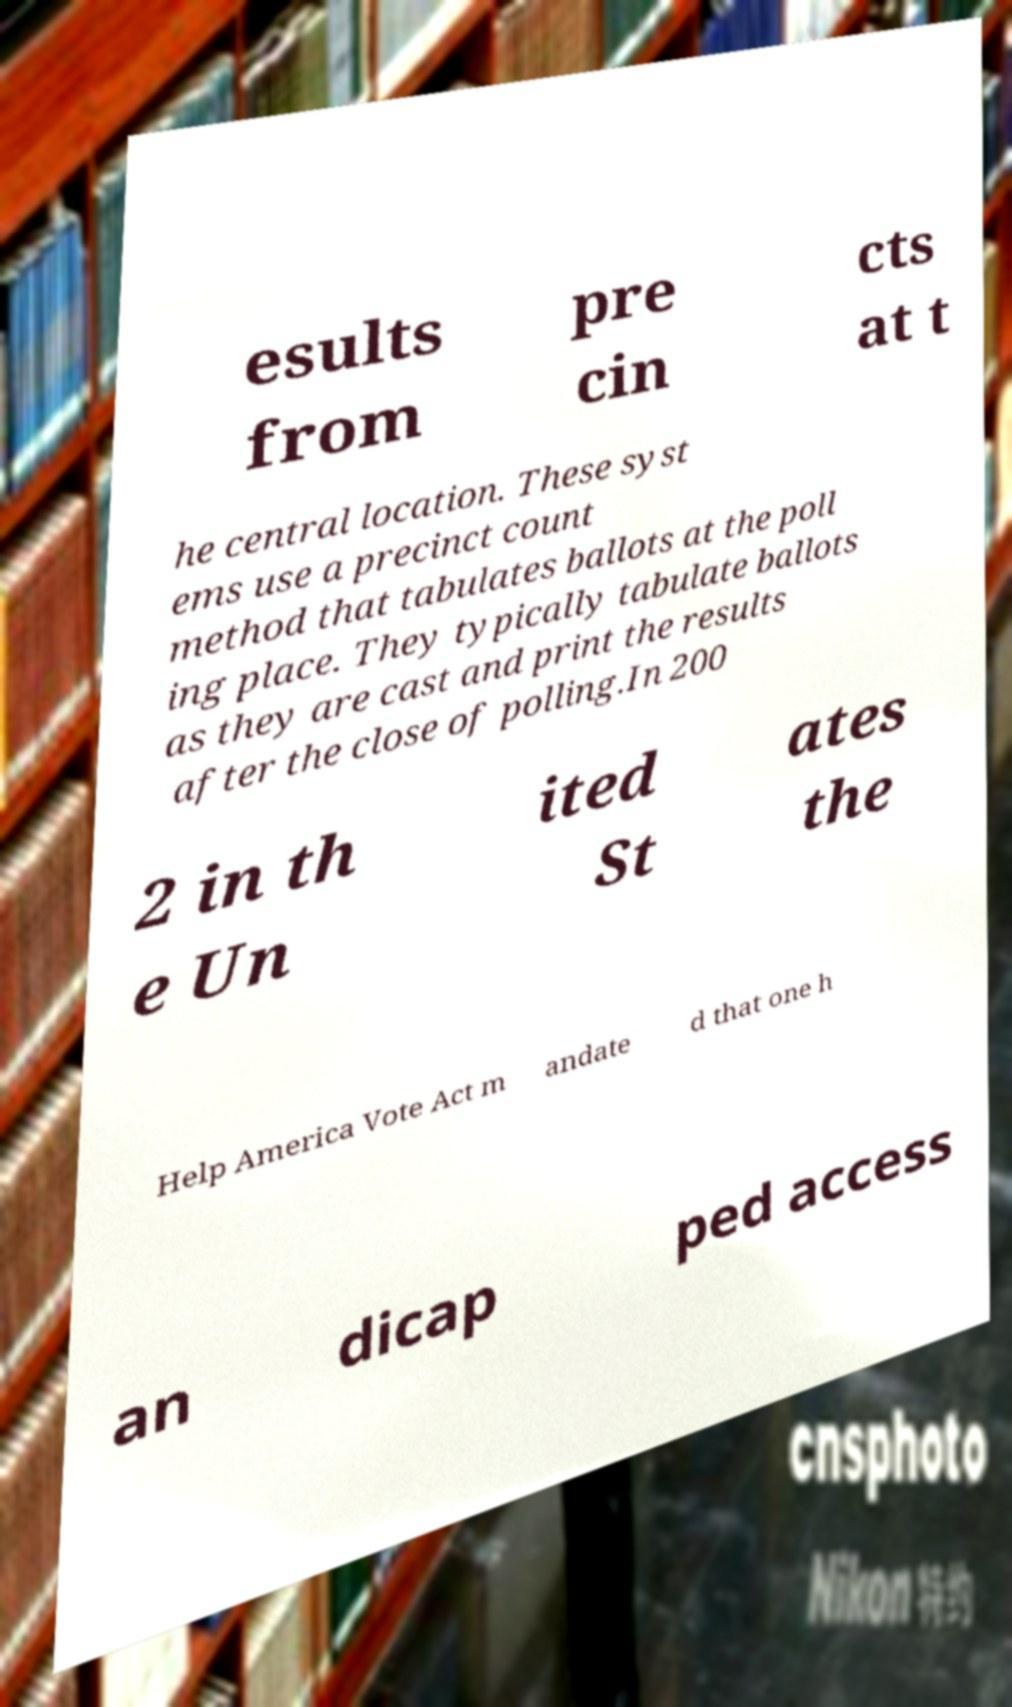Can you accurately transcribe the text from the provided image for me? esults from pre cin cts at t he central location. These syst ems use a precinct count method that tabulates ballots at the poll ing place. They typically tabulate ballots as they are cast and print the results after the close of polling.In 200 2 in th e Un ited St ates the Help America Vote Act m andate d that one h an dicap ped access 